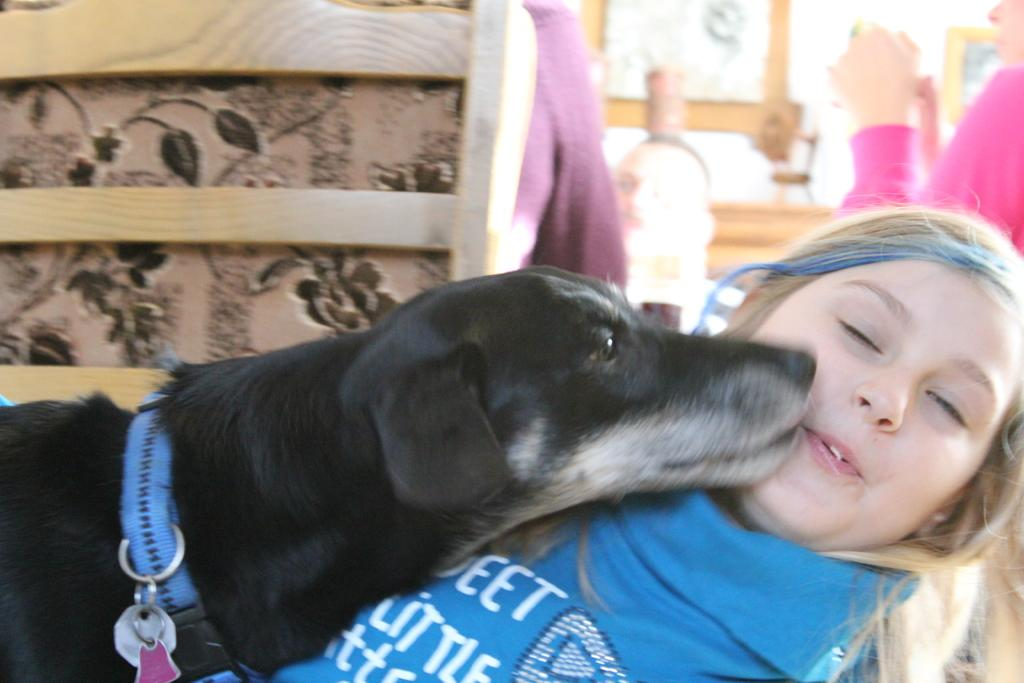Who is the main subject in the foreground of the image? There is a girl in the foreground of the image. What is the girl doing in the image? There is a dog on the girl. What can be seen in the background of the image? There are people sitting in chairs in the background of the image. What type of light is shining on the girl's sock in the image? There is no mention of a light or a sock in the image, so it cannot be determined if a light is shining on a sock. 